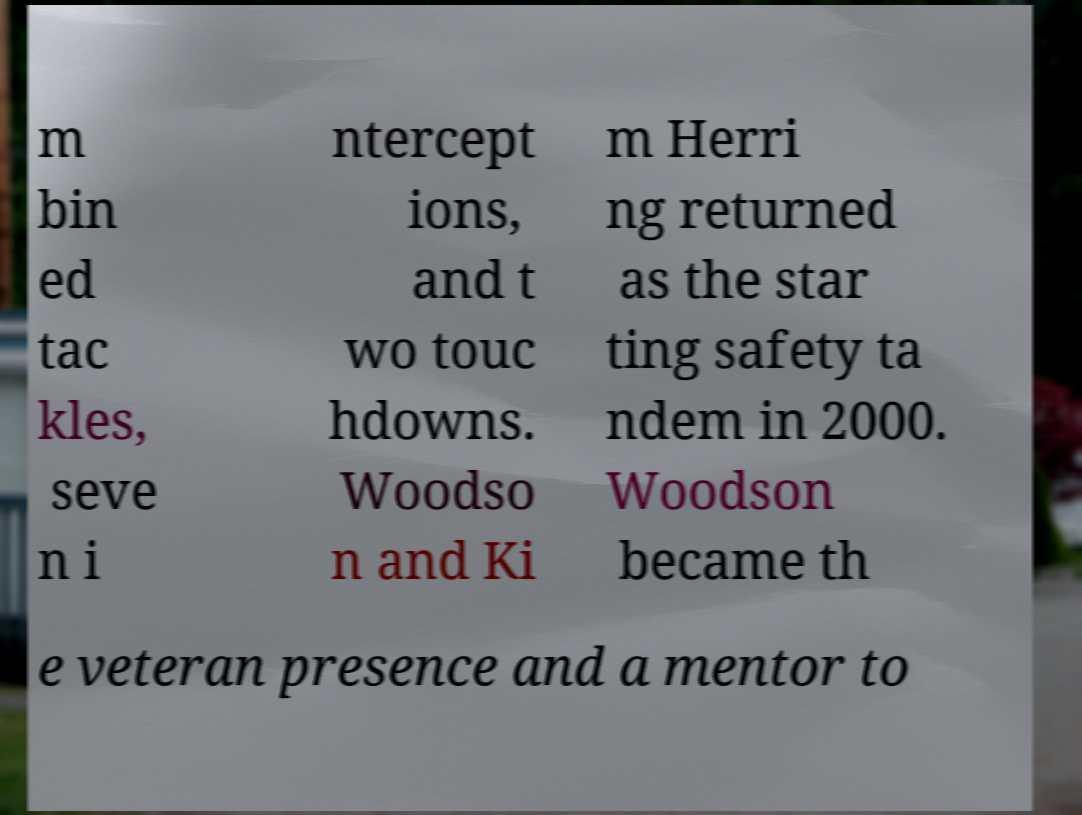Please identify and transcribe the text found in this image. m bin ed tac kles, seve n i ntercept ions, and t wo touc hdowns. Woodso n and Ki m Herri ng returned as the star ting safety ta ndem in 2000. Woodson became th e veteran presence and a mentor to 